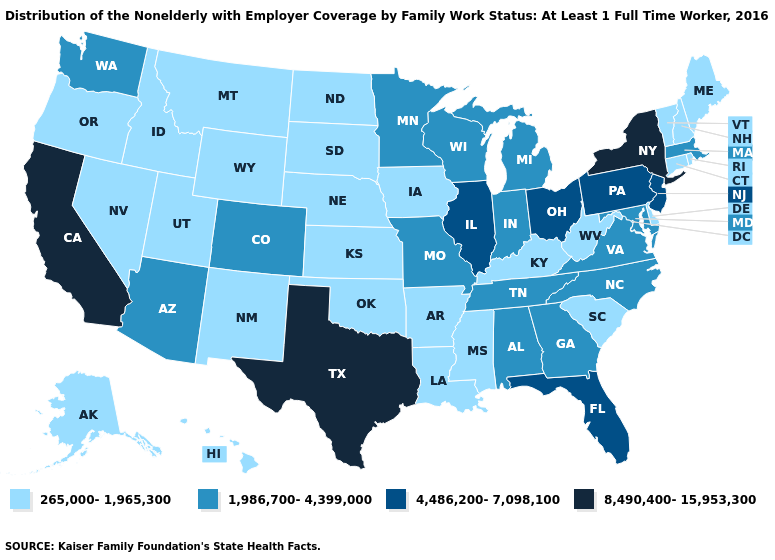Does the first symbol in the legend represent the smallest category?
Short answer required. Yes. What is the lowest value in the South?
Short answer required. 265,000-1,965,300. What is the value of Oklahoma?
Concise answer only. 265,000-1,965,300. Does California have the highest value in the West?
Concise answer only. Yes. Name the states that have a value in the range 4,486,200-7,098,100?
Be succinct. Florida, Illinois, New Jersey, Ohio, Pennsylvania. What is the value of Illinois?
Be succinct. 4,486,200-7,098,100. What is the highest value in the West ?
Give a very brief answer. 8,490,400-15,953,300. Which states have the highest value in the USA?
Concise answer only. California, New York, Texas. Which states have the highest value in the USA?
Give a very brief answer. California, New York, Texas. Does New York have the highest value in the USA?
Answer briefly. Yes. Does the first symbol in the legend represent the smallest category?
Keep it brief. Yes. Does Oklahoma have the lowest value in the South?
Short answer required. Yes. Does Texas have the highest value in the South?
Quick response, please. Yes. Which states have the lowest value in the South?
Short answer required. Arkansas, Delaware, Kentucky, Louisiana, Mississippi, Oklahoma, South Carolina, West Virginia. Name the states that have a value in the range 8,490,400-15,953,300?
Quick response, please. California, New York, Texas. 